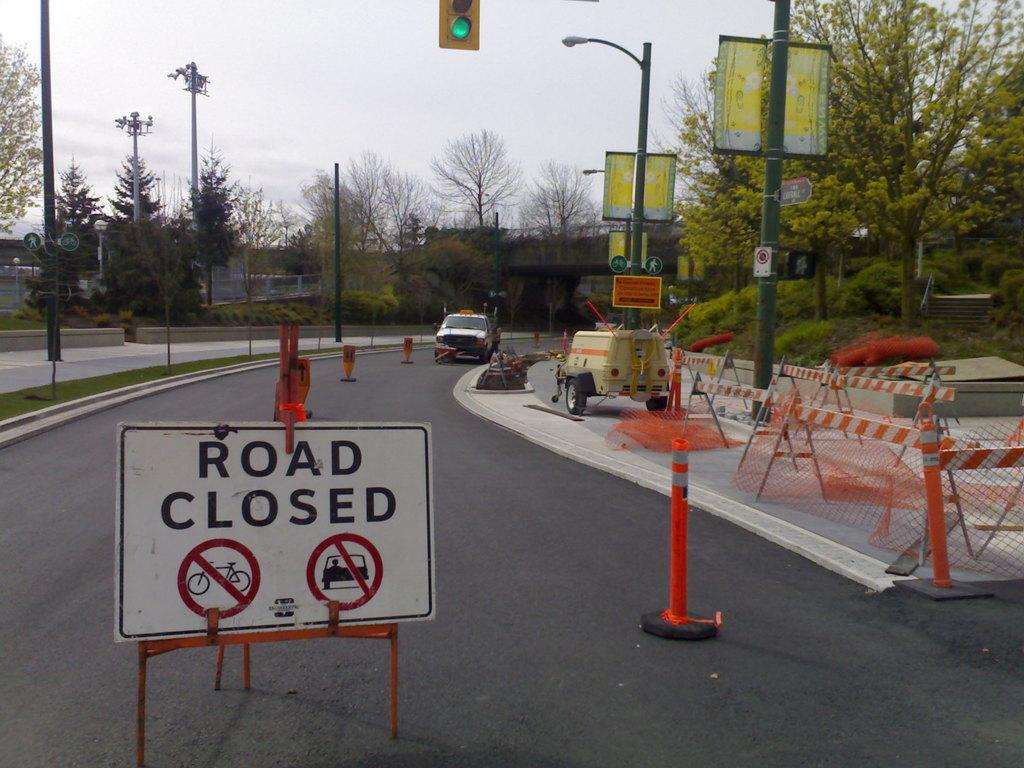<image>
Relay a brief, clear account of the picture shown. Road with a white sign that reads "Road Closed". 